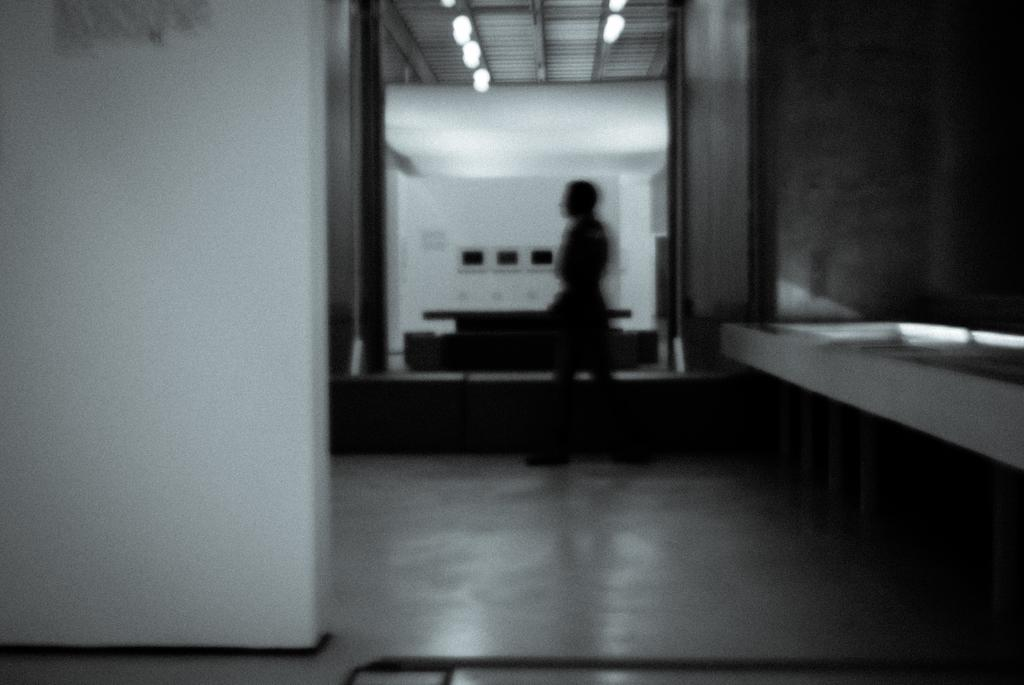Who or what is the main subject in the middle of the image? There is a person in the middle of the image. What is the surface beneath the person? There is a floor at the bottom of the image. Where was the image taken? The image was taken inside a building. What can be seen in the background of the image? There are lights, a table, and a wall in the background of the image. What type of button is the secretary wearing in the image? There is no secretary or button present in the image. How many family members are visible in the image? There are no family members present in the image; it only features a person. 